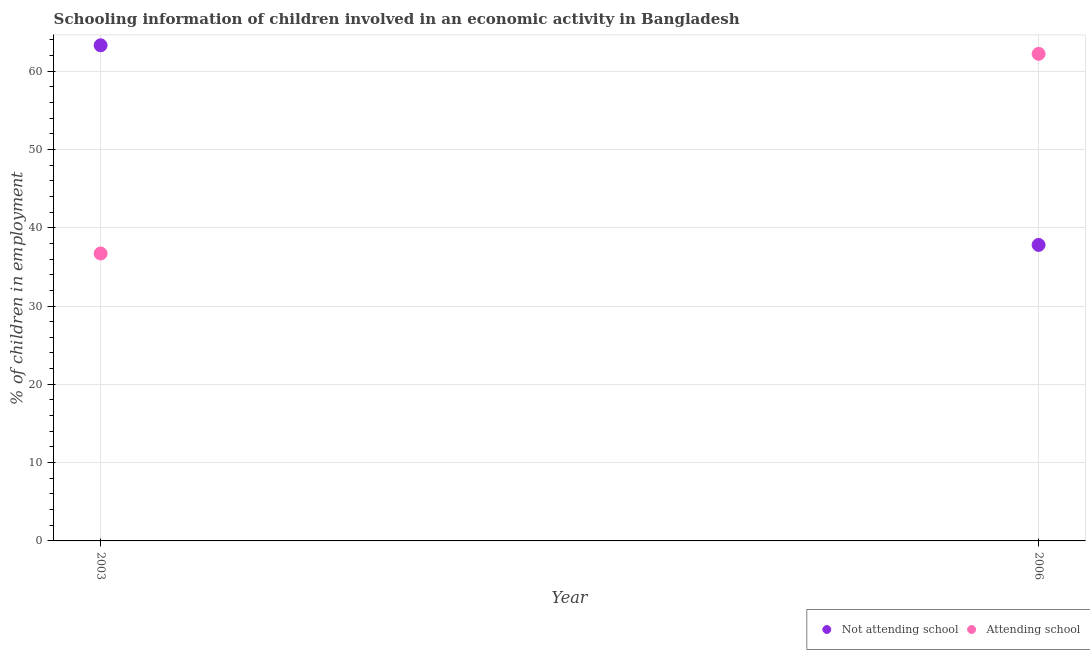What is the percentage of employed children who are attending school in 2006?
Offer a very short reply. 62.2. Across all years, what is the maximum percentage of employed children who are not attending school?
Give a very brief answer. 63.29. Across all years, what is the minimum percentage of employed children who are not attending school?
Your response must be concise. 37.8. In which year was the percentage of employed children who are attending school minimum?
Ensure brevity in your answer.  2003. What is the total percentage of employed children who are not attending school in the graph?
Your answer should be compact. 101.09. What is the difference between the percentage of employed children who are not attending school in 2003 and that in 2006?
Your response must be concise. 25.49. What is the difference between the percentage of employed children who are attending school in 2003 and the percentage of employed children who are not attending school in 2006?
Your response must be concise. -1.09. What is the average percentage of employed children who are attending school per year?
Your response must be concise. 49.45. In the year 2003, what is the difference between the percentage of employed children who are attending school and percentage of employed children who are not attending school?
Your response must be concise. -26.59. In how many years, is the percentage of employed children who are not attending school greater than 10 %?
Your answer should be very brief. 2. What is the ratio of the percentage of employed children who are not attending school in 2003 to that in 2006?
Provide a succinct answer. 1.67. Is the percentage of employed children who are not attending school in 2003 less than that in 2006?
Offer a terse response. No. In how many years, is the percentage of employed children who are not attending school greater than the average percentage of employed children who are not attending school taken over all years?
Ensure brevity in your answer.  1. Is the percentage of employed children who are not attending school strictly greater than the percentage of employed children who are attending school over the years?
Your answer should be very brief. No. What is the difference between two consecutive major ticks on the Y-axis?
Keep it short and to the point. 10. Are the values on the major ticks of Y-axis written in scientific E-notation?
Your response must be concise. No. How are the legend labels stacked?
Ensure brevity in your answer.  Horizontal. What is the title of the graph?
Provide a succinct answer. Schooling information of children involved in an economic activity in Bangladesh. Does "Male" appear as one of the legend labels in the graph?
Provide a short and direct response. No. What is the label or title of the X-axis?
Provide a succinct answer. Year. What is the label or title of the Y-axis?
Keep it short and to the point. % of children in employment. What is the % of children in employment in Not attending school in 2003?
Provide a succinct answer. 63.29. What is the % of children in employment in Attending school in 2003?
Offer a very short reply. 36.71. What is the % of children in employment of Not attending school in 2006?
Ensure brevity in your answer.  37.8. What is the % of children in employment of Attending school in 2006?
Make the answer very short. 62.2. Across all years, what is the maximum % of children in employment in Not attending school?
Your answer should be compact. 63.29. Across all years, what is the maximum % of children in employment of Attending school?
Ensure brevity in your answer.  62.2. Across all years, what is the minimum % of children in employment of Not attending school?
Provide a short and direct response. 37.8. Across all years, what is the minimum % of children in employment of Attending school?
Offer a terse response. 36.71. What is the total % of children in employment in Not attending school in the graph?
Keep it short and to the point. 101.09. What is the total % of children in employment in Attending school in the graph?
Keep it short and to the point. 98.91. What is the difference between the % of children in employment of Not attending school in 2003 and that in 2006?
Your answer should be very brief. 25.49. What is the difference between the % of children in employment of Attending school in 2003 and that in 2006?
Your answer should be very brief. -25.49. What is the difference between the % of children in employment of Not attending school in 2003 and the % of children in employment of Attending school in 2006?
Provide a short and direct response. 1.09. What is the average % of children in employment of Not attending school per year?
Offer a very short reply. 50.55. What is the average % of children in employment in Attending school per year?
Your answer should be very brief. 49.45. In the year 2003, what is the difference between the % of children in employment of Not attending school and % of children in employment of Attending school?
Make the answer very short. 26.59. In the year 2006, what is the difference between the % of children in employment in Not attending school and % of children in employment in Attending school?
Your answer should be compact. -24.4. What is the ratio of the % of children in employment of Not attending school in 2003 to that in 2006?
Keep it short and to the point. 1.67. What is the ratio of the % of children in employment in Attending school in 2003 to that in 2006?
Make the answer very short. 0.59. What is the difference between the highest and the second highest % of children in employment of Not attending school?
Offer a terse response. 25.49. What is the difference between the highest and the second highest % of children in employment in Attending school?
Your response must be concise. 25.49. What is the difference between the highest and the lowest % of children in employment of Not attending school?
Make the answer very short. 25.49. What is the difference between the highest and the lowest % of children in employment in Attending school?
Your answer should be very brief. 25.49. 